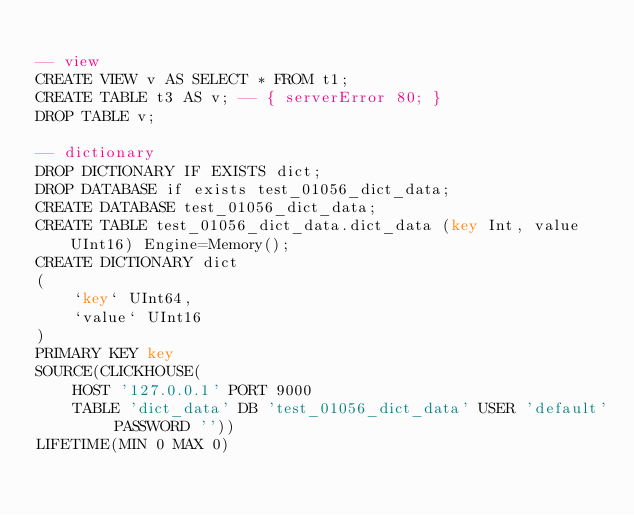Convert code to text. <code><loc_0><loc_0><loc_500><loc_500><_SQL_>
-- view
CREATE VIEW v AS SELECT * FROM t1;
CREATE TABLE t3 AS v; -- { serverError 80; }
DROP TABLE v;

-- dictionary
DROP DICTIONARY IF EXISTS dict;
DROP DATABASE if exists test_01056_dict_data;
CREATE DATABASE test_01056_dict_data;
CREATE TABLE test_01056_dict_data.dict_data (key Int, value UInt16) Engine=Memory();
CREATE DICTIONARY dict
(
    `key` UInt64,
    `value` UInt16
)
PRIMARY KEY key
SOURCE(CLICKHOUSE(
    HOST '127.0.0.1' PORT 9000
    TABLE 'dict_data' DB 'test_01056_dict_data' USER 'default' PASSWORD ''))
LIFETIME(MIN 0 MAX 0)</code> 